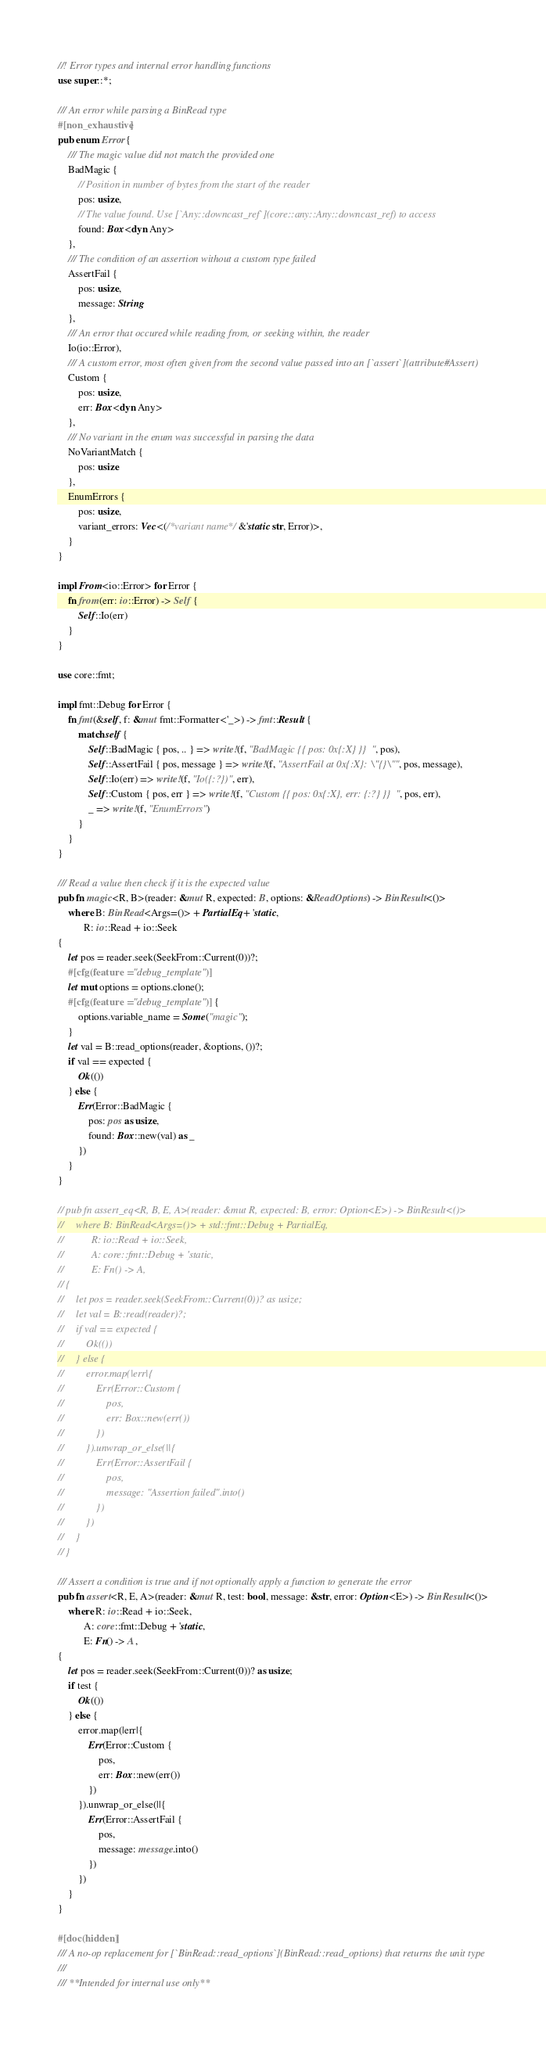<code> <loc_0><loc_0><loc_500><loc_500><_Rust_>//! Error types and internal error handling functions
use super::*;

/// An error while parsing a BinRead type
#[non_exhaustive]
pub enum Error {
    /// The magic value did not match the provided one
    BadMagic {
        // Position in number of bytes from the start of the reader
        pos: usize,
        // The value found. Use [`Any::downcast_ref`](core::any::Any::downcast_ref) to access
        found: Box<dyn Any>
    },
    /// The condition of an assertion without a custom type failed
    AssertFail {
        pos: usize,
        message: String
    },
    /// An error that occured while reading from, or seeking within, the reader
    Io(io::Error),
    /// A custom error, most often given from the second value passed into an [`assert`](attribute#Assert)
    Custom {
        pos: usize,
        err: Box<dyn Any>
    },
    /// No variant in the enum was successful in parsing the data
    NoVariantMatch {
        pos: usize
    },
    EnumErrors {
        pos: usize,
        variant_errors: Vec<(/*variant name*/ &'static str, Error)>,
    }
}

impl From<io::Error> for Error {
    fn from(err: io::Error) -> Self {
        Self::Io(err)
    }
}

use core::fmt;

impl fmt::Debug for Error {
    fn fmt(&self, f: &mut fmt::Formatter<'_>) -> fmt::Result {
        match self {
            Self::BadMagic { pos, .. } => write!(f, "BadMagic {{ pos: 0x{:X} }}", pos),
            Self::AssertFail { pos, message } => write!(f, "AssertFail at 0x{:X}: \"{}\"", pos, message),
            Self::Io(err) => write!(f, "Io({:?})", err),
            Self::Custom { pos, err } => write!(f, "Custom {{ pos: 0x{:X}, err: {:?} }}", pos, err),
            _ => write!(f, "EnumErrors")
        }
    }
}

/// Read a value then check if it is the expected value
pub fn magic<R, B>(reader: &mut R, expected: B, options: &ReadOptions) -> BinResult<()>
    where B: BinRead<Args=()> + PartialEq + 'static,
          R: io::Read + io::Seek
{
    let pos = reader.seek(SeekFrom::Current(0))?;
    #[cfg(feature = "debug_template")]
    let mut options = options.clone();
    #[cfg(feature = "debug_template")] {
        options.variable_name = Some("magic");
    }
    let val = B::read_options(reader, &options, ())?;
    if val == expected {
        Ok(())
    } else {
        Err(Error::BadMagic {
            pos: pos as usize,
            found: Box::new(val) as _
        })
    }
}

// pub fn assert_eq<R, B, E, A>(reader: &mut R, expected: B, error: Option<E>) -> BinResult<()>
//     where B: BinRead<Args=()> + std::fmt::Debug + PartialEq,
//           R: io::Read + io::Seek,
//           A: core::fmt::Debug + 'static,
//           E: Fn() -> A,
// {
//     let pos = reader.seek(SeekFrom::Current(0))? as usize;
//     let val = B::read(reader)?;
//     if val == expected {
//         Ok(())
//     } else {
//         error.map(|err|{
//             Err(Error::Custom {
//                 pos,
//                 err: Box::new(err())
//             })
//         }).unwrap_or_else(||{
//             Err(Error::AssertFail {
//                 pos,
//                 message: "Assertion failed".into()
//             })
//         })
//     }
// }

/// Assert a condition is true and if not optionally apply a function to generate the error
pub fn assert<R, E, A>(reader: &mut R, test: bool, message: &str, error: Option<E>) -> BinResult<()>
    where R: io::Read + io::Seek,
          A: core::fmt::Debug + 'static,
          E: Fn() -> A,
{
    let pos = reader.seek(SeekFrom::Current(0))? as usize;
    if test {
        Ok(())
    } else {
        error.map(|err|{
            Err(Error::Custom {
                pos,
                err: Box::new(err())
            })
        }).unwrap_or_else(||{
            Err(Error::AssertFail {
                pos,
                message: message.into()
            })
        })
    }
}

#[doc(hidden)]
/// A no-op replacement for [`BinRead::read_options`](BinRead::read_options) that returns the unit type
/// 
/// **Intended for internal use only**</code> 